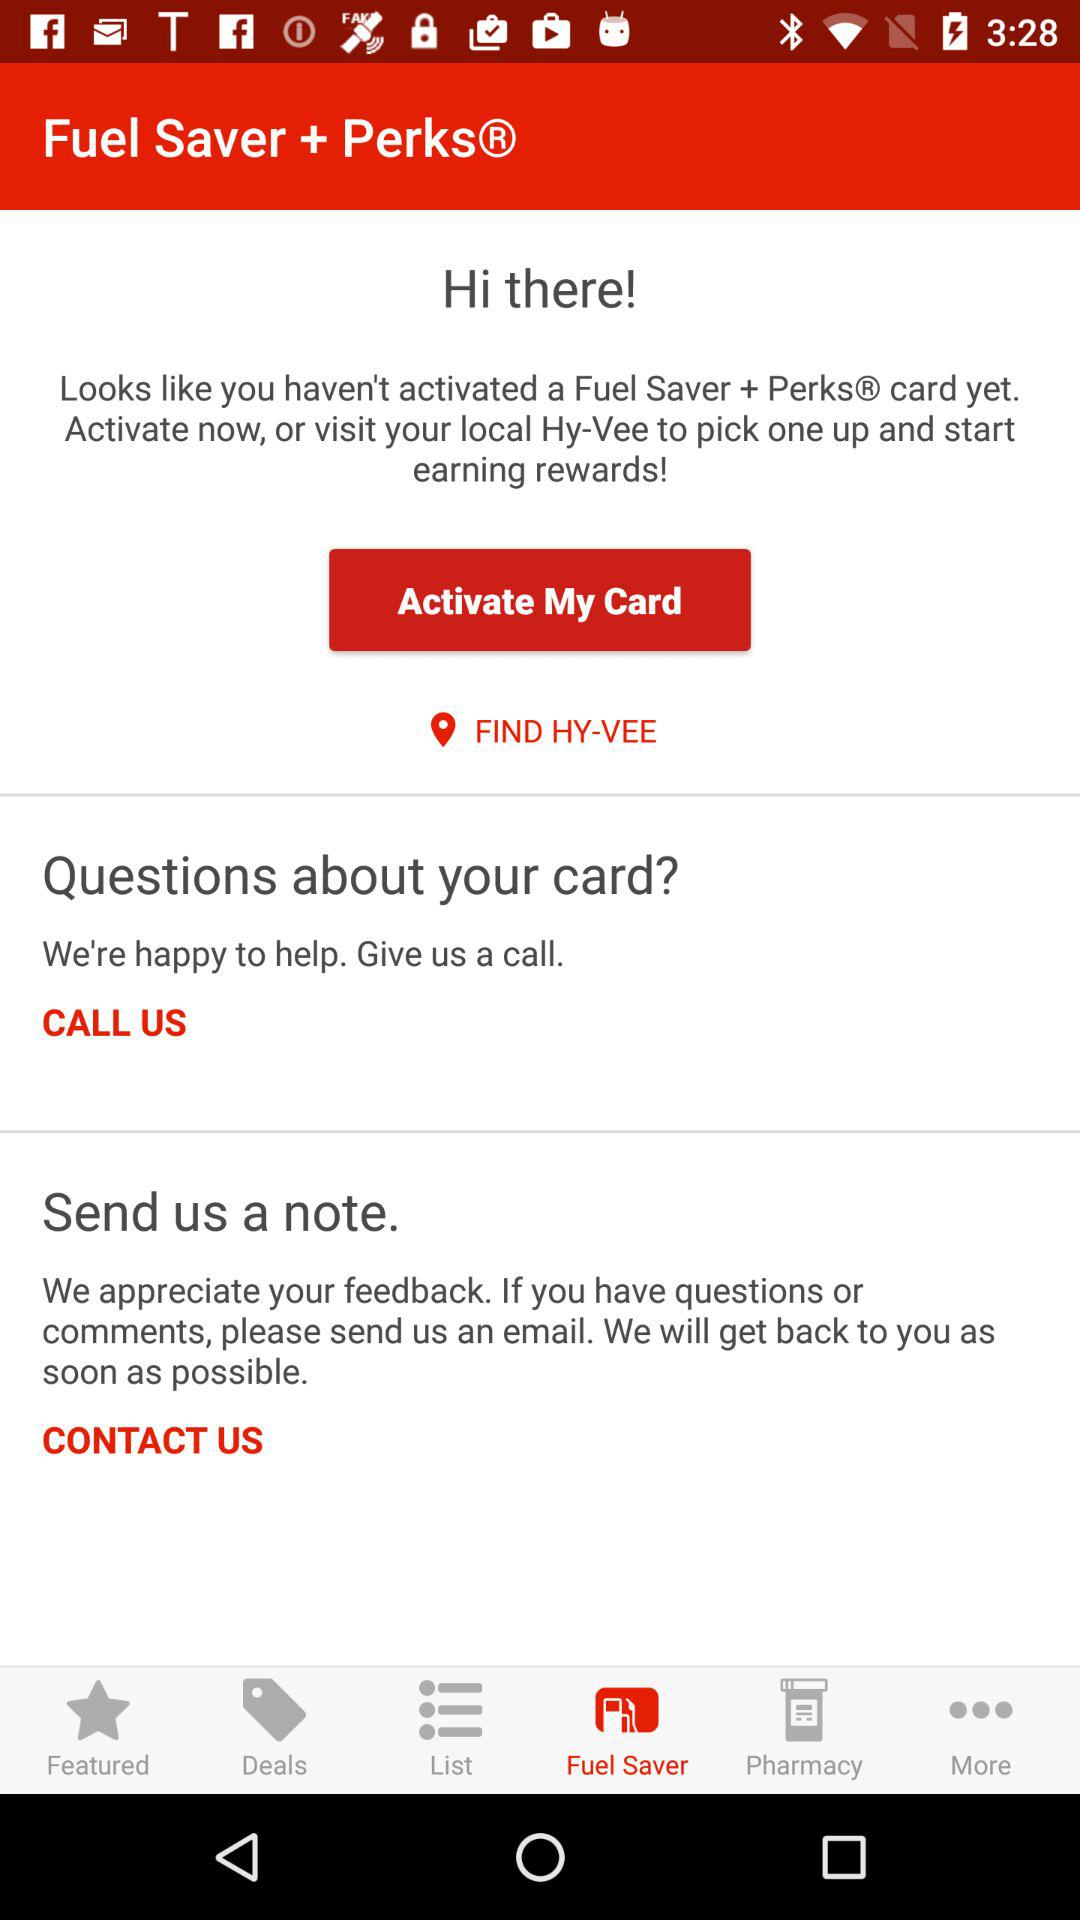Which tab is selected? The selected tab is "Fuel Saver". 